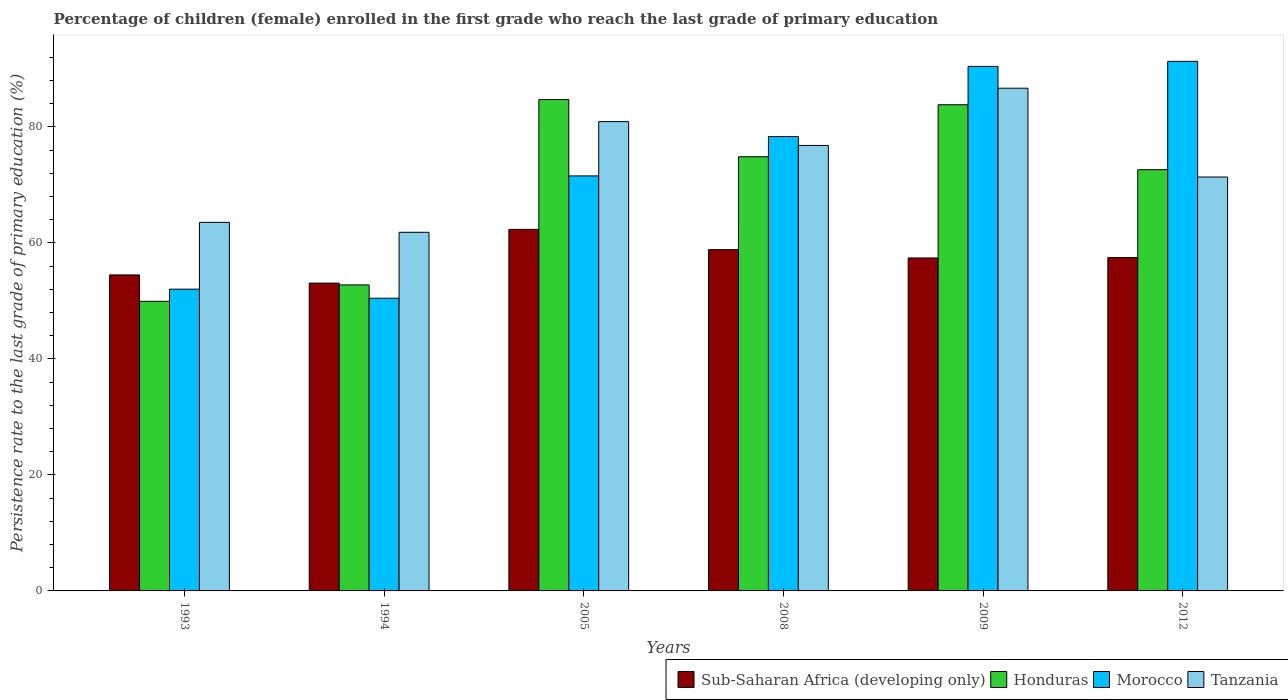How many different coloured bars are there?
Keep it short and to the point. 4. How many bars are there on the 1st tick from the left?
Your response must be concise. 4. How many bars are there on the 4th tick from the right?
Your response must be concise. 4. In how many cases, is the number of bars for a given year not equal to the number of legend labels?
Your answer should be compact. 0. What is the persistence rate of children in Sub-Saharan Africa (developing only) in 2009?
Your response must be concise. 57.41. Across all years, what is the maximum persistence rate of children in Honduras?
Provide a succinct answer. 84.72. Across all years, what is the minimum persistence rate of children in Morocco?
Make the answer very short. 50.47. In which year was the persistence rate of children in Sub-Saharan Africa (developing only) maximum?
Ensure brevity in your answer.  2005. What is the total persistence rate of children in Morocco in the graph?
Provide a succinct answer. 434.16. What is the difference between the persistence rate of children in Honduras in 1993 and that in 2009?
Ensure brevity in your answer.  -33.9. What is the difference between the persistence rate of children in Honduras in 2008 and the persistence rate of children in Morocco in 2005?
Offer a very short reply. 3.31. What is the average persistence rate of children in Tanzania per year?
Provide a short and direct response. 73.53. In the year 1994, what is the difference between the persistence rate of children in Tanzania and persistence rate of children in Honduras?
Provide a succinct answer. 9.07. In how many years, is the persistence rate of children in Tanzania greater than 64 %?
Your answer should be very brief. 4. What is the ratio of the persistence rate of children in Honduras in 1994 to that in 2012?
Your response must be concise. 0.73. Is the persistence rate of children in Sub-Saharan Africa (developing only) in 2005 less than that in 2008?
Your answer should be very brief. No. Is the difference between the persistence rate of children in Tanzania in 1993 and 1994 greater than the difference between the persistence rate of children in Honduras in 1993 and 1994?
Your answer should be very brief. Yes. What is the difference between the highest and the second highest persistence rate of children in Sub-Saharan Africa (developing only)?
Give a very brief answer. 3.5. What is the difference between the highest and the lowest persistence rate of children in Morocco?
Your response must be concise. 40.85. In how many years, is the persistence rate of children in Honduras greater than the average persistence rate of children in Honduras taken over all years?
Offer a terse response. 4. Is the sum of the persistence rate of children in Morocco in 2005 and 2012 greater than the maximum persistence rate of children in Tanzania across all years?
Your response must be concise. Yes. What does the 4th bar from the left in 1994 represents?
Make the answer very short. Tanzania. What does the 1st bar from the right in 1994 represents?
Provide a succinct answer. Tanzania. How many bars are there?
Provide a succinct answer. 24. How many years are there in the graph?
Keep it short and to the point. 6. What is the difference between two consecutive major ticks on the Y-axis?
Offer a terse response. 20. Are the values on the major ticks of Y-axis written in scientific E-notation?
Ensure brevity in your answer.  No. Does the graph contain grids?
Make the answer very short. No. How many legend labels are there?
Provide a succinct answer. 4. What is the title of the graph?
Your answer should be very brief. Percentage of children (female) enrolled in the first grade who reach the last grade of primary education. What is the label or title of the X-axis?
Keep it short and to the point. Years. What is the label or title of the Y-axis?
Your answer should be very brief. Persistence rate to the last grade of primary education (%). What is the Persistence rate to the last grade of primary education (%) of Sub-Saharan Africa (developing only) in 1993?
Provide a short and direct response. 54.49. What is the Persistence rate to the last grade of primary education (%) in Honduras in 1993?
Keep it short and to the point. 49.94. What is the Persistence rate to the last grade of primary education (%) in Morocco in 1993?
Keep it short and to the point. 52.03. What is the Persistence rate to the last grade of primary education (%) in Tanzania in 1993?
Offer a very short reply. 63.55. What is the Persistence rate to the last grade of primary education (%) of Sub-Saharan Africa (developing only) in 1994?
Your answer should be compact. 53.08. What is the Persistence rate to the last grade of primary education (%) of Honduras in 1994?
Offer a very short reply. 52.77. What is the Persistence rate to the last grade of primary education (%) in Morocco in 1994?
Keep it short and to the point. 50.47. What is the Persistence rate to the last grade of primary education (%) in Tanzania in 1994?
Give a very brief answer. 61.84. What is the Persistence rate to the last grade of primary education (%) in Sub-Saharan Africa (developing only) in 2005?
Your response must be concise. 62.34. What is the Persistence rate to the last grade of primary education (%) of Honduras in 2005?
Your answer should be very brief. 84.72. What is the Persistence rate to the last grade of primary education (%) in Morocco in 2005?
Ensure brevity in your answer.  71.56. What is the Persistence rate to the last grade of primary education (%) in Tanzania in 2005?
Ensure brevity in your answer.  80.92. What is the Persistence rate to the last grade of primary education (%) of Sub-Saharan Africa (developing only) in 2008?
Provide a short and direct response. 58.85. What is the Persistence rate to the last grade of primary education (%) in Honduras in 2008?
Your response must be concise. 74.87. What is the Persistence rate to the last grade of primary education (%) of Morocco in 2008?
Give a very brief answer. 78.34. What is the Persistence rate to the last grade of primary education (%) in Tanzania in 2008?
Provide a short and direct response. 76.81. What is the Persistence rate to the last grade of primary education (%) of Sub-Saharan Africa (developing only) in 2009?
Provide a succinct answer. 57.41. What is the Persistence rate to the last grade of primary education (%) in Honduras in 2009?
Your answer should be compact. 83.83. What is the Persistence rate to the last grade of primary education (%) of Morocco in 2009?
Offer a terse response. 90.44. What is the Persistence rate to the last grade of primary education (%) in Tanzania in 2009?
Your answer should be very brief. 86.68. What is the Persistence rate to the last grade of primary education (%) of Sub-Saharan Africa (developing only) in 2012?
Ensure brevity in your answer.  57.48. What is the Persistence rate to the last grade of primary education (%) of Honduras in 2012?
Give a very brief answer. 72.63. What is the Persistence rate to the last grade of primary education (%) of Morocco in 2012?
Provide a short and direct response. 91.32. What is the Persistence rate to the last grade of primary education (%) in Tanzania in 2012?
Your answer should be compact. 71.37. Across all years, what is the maximum Persistence rate to the last grade of primary education (%) in Sub-Saharan Africa (developing only)?
Offer a terse response. 62.34. Across all years, what is the maximum Persistence rate to the last grade of primary education (%) of Honduras?
Give a very brief answer. 84.72. Across all years, what is the maximum Persistence rate to the last grade of primary education (%) in Morocco?
Provide a succinct answer. 91.32. Across all years, what is the maximum Persistence rate to the last grade of primary education (%) of Tanzania?
Offer a terse response. 86.68. Across all years, what is the minimum Persistence rate to the last grade of primary education (%) in Sub-Saharan Africa (developing only)?
Offer a very short reply. 53.08. Across all years, what is the minimum Persistence rate to the last grade of primary education (%) of Honduras?
Offer a terse response. 49.94. Across all years, what is the minimum Persistence rate to the last grade of primary education (%) of Morocco?
Your answer should be very brief. 50.47. Across all years, what is the minimum Persistence rate to the last grade of primary education (%) in Tanzania?
Give a very brief answer. 61.84. What is the total Persistence rate to the last grade of primary education (%) of Sub-Saharan Africa (developing only) in the graph?
Offer a very short reply. 343.65. What is the total Persistence rate to the last grade of primary education (%) in Honduras in the graph?
Give a very brief answer. 418.77. What is the total Persistence rate to the last grade of primary education (%) of Morocco in the graph?
Your answer should be compact. 434.16. What is the total Persistence rate to the last grade of primary education (%) in Tanzania in the graph?
Your response must be concise. 441.18. What is the difference between the Persistence rate to the last grade of primary education (%) in Sub-Saharan Africa (developing only) in 1993 and that in 1994?
Give a very brief answer. 1.41. What is the difference between the Persistence rate to the last grade of primary education (%) in Honduras in 1993 and that in 1994?
Offer a terse response. -2.83. What is the difference between the Persistence rate to the last grade of primary education (%) of Morocco in 1993 and that in 1994?
Keep it short and to the point. 1.56. What is the difference between the Persistence rate to the last grade of primary education (%) in Tanzania in 1993 and that in 1994?
Your answer should be very brief. 1.71. What is the difference between the Persistence rate to the last grade of primary education (%) of Sub-Saharan Africa (developing only) in 1993 and that in 2005?
Offer a very short reply. -7.86. What is the difference between the Persistence rate to the last grade of primary education (%) in Honduras in 1993 and that in 2005?
Offer a very short reply. -34.79. What is the difference between the Persistence rate to the last grade of primary education (%) of Morocco in 1993 and that in 2005?
Ensure brevity in your answer.  -19.53. What is the difference between the Persistence rate to the last grade of primary education (%) of Tanzania in 1993 and that in 2005?
Your response must be concise. -17.37. What is the difference between the Persistence rate to the last grade of primary education (%) in Sub-Saharan Africa (developing only) in 1993 and that in 2008?
Ensure brevity in your answer.  -4.36. What is the difference between the Persistence rate to the last grade of primary education (%) of Honduras in 1993 and that in 2008?
Keep it short and to the point. -24.93. What is the difference between the Persistence rate to the last grade of primary education (%) of Morocco in 1993 and that in 2008?
Your answer should be very brief. -26.31. What is the difference between the Persistence rate to the last grade of primary education (%) in Tanzania in 1993 and that in 2008?
Ensure brevity in your answer.  -13.26. What is the difference between the Persistence rate to the last grade of primary education (%) of Sub-Saharan Africa (developing only) in 1993 and that in 2009?
Give a very brief answer. -2.93. What is the difference between the Persistence rate to the last grade of primary education (%) in Honduras in 1993 and that in 2009?
Your answer should be very brief. -33.9. What is the difference between the Persistence rate to the last grade of primary education (%) of Morocco in 1993 and that in 2009?
Make the answer very short. -38.41. What is the difference between the Persistence rate to the last grade of primary education (%) in Tanzania in 1993 and that in 2009?
Your answer should be very brief. -23.13. What is the difference between the Persistence rate to the last grade of primary education (%) in Sub-Saharan Africa (developing only) in 1993 and that in 2012?
Offer a very short reply. -3. What is the difference between the Persistence rate to the last grade of primary education (%) in Honduras in 1993 and that in 2012?
Your answer should be compact. -22.7. What is the difference between the Persistence rate to the last grade of primary education (%) in Morocco in 1993 and that in 2012?
Offer a terse response. -39.28. What is the difference between the Persistence rate to the last grade of primary education (%) in Tanzania in 1993 and that in 2012?
Your answer should be very brief. -7.82. What is the difference between the Persistence rate to the last grade of primary education (%) in Sub-Saharan Africa (developing only) in 1994 and that in 2005?
Provide a short and direct response. -9.27. What is the difference between the Persistence rate to the last grade of primary education (%) of Honduras in 1994 and that in 2005?
Your response must be concise. -31.96. What is the difference between the Persistence rate to the last grade of primary education (%) in Morocco in 1994 and that in 2005?
Provide a succinct answer. -21.09. What is the difference between the Persistence rate to the last grade of primary education (%) of Tanzania in 1994 and that in 2005?
Provide a succinct answer. -19.08. What is the difference between the Persistence rate to the last grade of primary education (%) in Sub-Saharan Africa (developing only) in 1994 and that in 2008?
Give a very brief answer. -5.77. What is the difference between the Persistence rate to the last grade of primary education (%) in Honduras in 1994 and that in 2008?
Your answer should be very brief. -22.1. What is the difference between the Persistence rate to the last grade of primary education (%) in Morocco in 1994 and that in 2008?
Your response must be concise. -27.87. What is the difference between the Persistence rate to the last grade of primary education (%) of Tanzania in 1994 and that in 2008?
Your response must be concise. -14.97. What is the difference between the Persistence rate to the last grade of primary education (%) of Sub-Saharan Africa (developing only) in 1994 and that in 2009?
Your response must be concise. -4.34. What is the difference between the Persistence rate to the last grade of primary education (%) in Honduras in 1994 and that in 2009?
Your answer should be very brief. -31.07. What is the difference between the Persistence rate to the last grade of primary education (%) in Morocco in 1994 and that in 2009?
Give a very brief answer. -39.98. What is the difference between the Persistence rate to the last grade of primary education (%) of Tanzania in 1994 and that in 2009?
Offer a terse response. -24.84. What is the difference between the Persistence rate to the last grade of primary education (%) in Sub-Saharan Africa (developing only) in 1994 and that in 2012?
Your response must be concise. -4.41. What is the difference between the Persistence rate to the last grade of primary education (%) in Honduras in 1994 and that in 2012?
Offer a very short reply. -19.87. What is the difference between the Persistence rate to the last grade of primary education (%) of Morocco in 1994 and that in 2012?
Ensure brevity in your answer.  -40.85. What is the difference between the Persistence rate to the last grade of primary education (%) of Tanzania in 1994 and that in 2012?
Give a very brief answer. -9.53. What is the difference between the Persistence rate to the last grade of primary education (%) in Sub-Saharan Africa (developing only) in 2005 and that in 2008?
Your answer should be compact. 3.5. What is the difference between the Persistence rate to the last grade of primary education (%) in Honduras in 2005 and that in 2008?
Give a very brief answer. 9.86. What is the difference between the Persistence rate to the last grade of primary education (%) in Morocco in 2005 and that in 2008?
Give a very brief answer. -6.78. What is the difference between the Persistence rate to the last grade of primary education (%) of Tanzania in 2005 and that in 2008?
Your response must be concise. 4.11. What is the difference between the Persistence rate to the last grade of primary education (%) in Sub-Saharan Africa (developing only) in 2005 and that in 2009?
Provide a short and direct response. 4.93. What is the difference between the Persistence rate to the last grade of primary education (%) of Honduras in 2005 and that in 2009?
Offer a very short reply. 0.89. What is the difference between the Persistence rate to the last grade of primary education (%) of Morocco in 2005 and that in 2009?
Keep it short and to the point. -18.88. What is the difference between the Persistence rate to the last grade of primary education (%) in Tanzania in 2005 and that in 2009?
Your response must be concise. -5.76. What is the difference between the Persistence rate to the last grade of primary education (%) of Sub-Saharan Africa (developing only) in 2005 and that in 2012?
Your answer should be very brief. 4.86. What is the difference between the Persistence rate to the last grade of primary education (%) of Honduras in 2005 and that in 2012?
Your answer should be compact. 12.09. What is the difference between the Persistence rate to the last grade of primary education (%) of Morocco in 2005 and that in 2012?
Keep it short and to the point. -19.75. What is the difference between the Persistence rate to the last grade of primary education (%) of Tanzania in 2005 and that in 2012?
Your answer should be compact. 9.56. What is the difference between the Persistence rate to the last grade of primary education (%) in Sub-Saharan Africa (developing only) in 2008 and that in 2009?
Provide a short and direct response. 1.43. What is the difference between the Persistence rate to the last grade of primary education (%) in Honduras in 2008 and that in 2009?
Ensure brevity in your answer.  -8.97. What is the difference between the Persistence rate to the last grade of primary education (%) of Morocco in 2008 and that in 2009?
Your answer should be very brief. -12.1. What is the difference between the Persistence rate to the last grade of primary education (%) in Tanzania in 2008 and that in 2009?
Provide a short and direct response. -9.87. What is the difference between the Persistence rate to the last grade of primary education (%) of Sub-Saharan Africa (developing only) in 2008 and that in 2012?
Make the answer very short. 1.36. What is the difference between the Persistence rate to the last grade of primary education (%) in Honduras in 2008 and that in 2012?
Ensure brevity in your answer.  2.23. What is the difference between the Persistence rate to the last grade of primary education (%) of Morocco in 2008 and that in 2012?
Your answer should be very brief. -12.97. What is the difference between the Persistence rate to the last grade of primary education (%) in Tanzania in 2008 and that in 2012?
Provide a succinct answer. 5.44. What is the difference between the Persistence rate to the last grade of primary education (%) of Sub-Saharan Africa (developing only) in 2009 and that in 2012?
Give a very brief answer. -0.07. What is the difference between the Persistence rate to the last grade of primary education (%) in Honduras in 2009 and that in 2012?
Keep it short and to the point. 11.2. What is the difference between the Persistence rate to the last grade of primary education (%) in Morocco in 2009 and that in 2012?
Provide a short and direct response. -0.87. What is the difference between the Persistence rate to the last grade of primary education (%) in Tanzania in 2009 and that in 2012?
Offer a very short reply. 15.31. What is the difference between the Persistence rate to the last grade of primary education (%) of Sub-Saharan Africa (developing only) in 1993 and the Persistence rate to the last grade of primary education (%) of Honduras in 1994?
Provide a short and direct response. 1.72. What is the difference between the Persistence rate to the last grade of primary education (%) in Sub-Saharan Africa (developing only) in 1993 and the Persistence rate to the last grade of primary education (%) in Morocco in 1994?
Your answer should be compact. 4.02. What is the difference between the Persistence rate to the last grade of primary education (%) in Sub-Saharan Africa (developing only) in 1993 and the Persistence rate to the last grade of primary education (%) in Tanzania in 1994?
Make the answer very short. -7.35. What is the difference between the Persistence rate to the last grade of primary education (%) in Honduras in 1993 and the Persistence rate to the last grade of primary education (%) in Morocco in 1994?
Your answer should be compact. -0.53. What is the difference between the Persistence rate to the last grade of primary education (%) in Honduras in 1993 and the Persistence rate to the last grade of primary education (%) in Tanzania in 1994?
Your answer should be very brief. -11.9. What is the difference between the Persistence rate to the last grade of primary education (%) of Morocco in 1993 and the Persistence rate to the last grade of primary education (%) of Tanzania in 1994?
Provide a succinct answer. -9.81. What is the difference between the Persistence rate to the last grade of primary education (%) of Sub-Saharan Africa (developing only) in 1993 and the Persistence rate to the last grade of primary education (%) of Honduras in 2005?
Offer a terse response. -30.24. What is the difference between the Persistence rate to the last grade of primary education (%) of Sub-Saharan Africa (developing only) in 1993 and the Persistence rate to the last grade of primary education (%) of Morocco in 2005?
Offer a very short reply. -17.07. What is the difference between the Persistence rate to the last grade of primary education (%) of Sub-Saharan Africa (developing only) in 1993 and the Persistence rate to the last grade of primary education (%) of Tanzania in 2005?
Make the answer very short. -26.44. What is the difference between the Persistence rate to the last grade of primary education (%) in Honduras in 1993 and the Persistence rate to the last grade of primary education (%) in Morocco in 2005?
Ensure brevity in your answer.  -21.62. What is the difference between the Persistence rate to the last grade of primary education (%) in Honduras in 1993 and the Persistence rate to the last grade of primary education (%) in Tanzania in 2005?
Your answer should be compact. -30.99. What is the difference between the Persistence rate to the last grade of primary education (%) in Morocco in 1993 and the Persistence rate to the last grade of primary education (%) in Tanzania in 2005?
Keep it short and to the point. -28.89. What is the difference between the Persistence rate to the last grade of primary education (%) in Sub-Saharan Africa (developing only) in 1993 and the Persistence rate to the last grade of primary education (%) in Honduras in 2008?
Offer a very short reply. -20.38. What is the difference between the Persistence rate to the last grade of primary education (%) of Sub-Saharan Africa (developing only) in 1993 and the Persistence rate to the last grade of primary education (%) of Morocco in 2008?
Make the answer very short. -23.86. What is the difference between the Persistence rate to the last grade of primary education (%) in Sub-Saharan Africa (developing only) in 1993 and the Persistence rate to the last grade of primary education (%) in Tanzania in 2008?
Your answer should be compact. -22.33. What is the difference between the Persistence rate to the last grade of primary education (%) of Honduras in 1993 and the Persistence rate to the last grade of primary education (%) of Morocco in 2008?
Your answer should be compact. -28.41. What is the difference between the Persistence rate to the last grade of primary education (%) of Honduras in 1993 and the Persistence rate to the last grade of primary education (%) of Tanzania in 2008?
Your response must be concise. -26.88. What is the difference between the Persistence rate to the last grade of primary education (%) in Morocco in 1993 and the Persistence rate to the last grade of primary education (%) in Tanzania in 2008?
Offer a terse response. -24.78. What is the difference between the Persistence rate to the last grade of primary education (%) of Sub-Saharan Africa (developing only) in 1993 and the Persistence rate to the last grade of primary education (%) of Honduras in 2009?
Provide a succinct answer. -29.35. What is the difference between the Persistence rate to the last grade of primary education (%) in Sub-Saharan Africa (developing only) in 1993 and the Persistence rate to the last grade of primary education (%) in Morocco in 2009?
Ensure brevity in your answer.  -35.96. What is the difference between the Persistence rate to the last grade of primary education (%) of Sub-Saharan Africa (developing only) in 1993 and the Persistence rate to the last grade of primary education (%) of Tanzania in 2009?
Provide a succinct answer. -32.2. What is the difference between the Persistence rate to the last grade of primary education (%) in Honduras in 1993 and the Persistence rate to the last grade of primary education (%) in Morocco in 2009?
Provide a short and direct response. -40.51. What is the difference between the Persistence rate to the last grade of primary education (%) of Honduras in 1993 and the Persistence rate to the last grade of primary education (%) of Tanzania in 2009?
Your answer should be compact. -36.75. What is the difference between the Persistence rate to the last grade of primary education (%) of Morocco in 1993 and the Persistence rate to the last grade of primary education (%) of Tanzania in 2009?
Make the answer very short. -34.65. What is the difference between the Persistence rate to the last grade of primary education (%) of Sub-Saharan Africa (developing only) in 1993 and the Persistence rate to the last grade of primary education (%) of Honduras in 2012?
Provide a succinct answer. -18.15. What is the difference between the Persistence rate to the last grade of primary education (%) of Sub-Saharan Africa (developing only) in 1993 and the Persistence rate to the last grade of primary education (%) of Morocco in 2012?
Offer a terse response. -36.83. What is the difference between the Persistence rate to the last grade of primary education (%) in Sub-Saharan Africa (developing only) in 1993 and the Persistence rate to the last grade of primary education (%) in Tanzania in 2012?
Give a very brief answer. -16.88. What is the difference between the Persistence rate to the last grade of primary education (%) of Honduras in 1993 and the Persistence rate to the last grade of primary education (%) of Morocco in 2012?
Keep it short and to the point. -41.38. What is the difference between the Persistence rate to the last grade of primary education (%) in Honduras in 1993 and the Persistence rate to the last grade of primary education (%) in Tanzania in 2012?
Your answer should be compact. -21.43. What is the difference between the Persistence rate to the last grade of primary education (%) in Morocco in 1993 and the Persistence rate to the last grade of primary education (%) in Tanzania in 2012?
Give a very brief answer. -19.34. What is the difference between the Persistence rate to the last grade of primary education (%) in Sub-Saharan Africa (developing only) in 1994 and the Persistence rate to the last grade of primary education (%) in Honduras in 2005?
Make the answer very short. -31.65. What is the difference between the Persistence rate to the last grade of primary education (%) in Sub-Saharan Africa (developing only) in 1994 and the Persistence rate to the last grade of primary education (%) in Morocco in 2005?
Your response must be concise. -18.48. What is the difference between the Persistence rate to the last grade of primary education (%) in Sub-Saharan Africa (developing only) in 1994 and the Persistence rate to the last grade of primary education (%) in Tanzania in 2005?
Ensure brevity in your answer.  -27.85. What is the difference between the Persistence rate to the last grade of primary education (%) of Honduras in 1994 and the Persistence rate to the last grade of primary education (%) of Morocco in 2005?
Your response must be concise. -18.79. What is the difference between the Persistence rate to the last grade of primary education (%) in Honduras in 1994 and the Persistence rate to the last grade of primary education (%) in Tanzania in 2005?
Give a very brief answer. -28.16. What is the difference between the Persistence rate to the last grade of primary education (%) in Morocco in 1994 and the Persistence rate to the last grade of primary education (%) in Tanzania in 2005?
Keep it short and to the point. -30.46. What is the difference between the Persistence rate to the last grade of primary education (%) of Sub-Saharan Africa (developing only) in 1994 and the Persistence rate to the last grade of primary education (%) of Honduras in 2008?
Offer a terse response. -21.79. What is the difference between the Persistence rate to the last grade of primary education (%) of Sub-Saharan Africa (developing only) in 1994 and the Persistence rate to the last grade of primary education (%) of Morocco in 2008?
Your answer should be compact. -25.26. What is the difference between the Persistence rate to the last grade of primary education (%) in Sub-Saharan Africa (developing only) in 1994 and the Persistence rate to the last grade of primary education (%) in Tanzania in 2008?
Provide a succinct answer. -23.74. What is the difference between the Persistence rate to the last grade of primary education (%) in Honduras in 1994 and the Persistence rate to the last grade of primary education (%) in Morocco in 2008?
Ensure brevity in your answer.  -25.58. What is the difference between the Persistence rate to the last grade of primary education (%) of Honduras in 1994 and the Persistence rate to the last grade of primary education (%) of Tanzania in 2008?
Ensure brevity in your answer.  -24.05. What is the difference between the Persistence rate to the last grade of primary education (%) of Morocco in 1994 and the Persistence rate to the last grade of primary education (%) of Tanzania in 2008?
Make the answer very short. -26.35. What is the difference between the Persistence rate to the last grade of primary education (%) of Sub-Saharan Africa (developing only) in 1994 and the Persistence rate to the last grade of primary education (%) of Honduras in 2009?
Provide a succinct answer. -30.76. What is the difference between the Persistence rate to the last grade of primary education (%) in Sub-Saharan Africa (developing only) in 1994 and the Persistence rate to the last grade of primary education (%) in Morocco in 2009?
Provide a short and direct response. -37.37. What is the difference between the Persistence rate to the last grade of primary education (%) in Sub-Saharan Africa (developing only) in 1994 and the Persistence rate to the last grade of primary education (%) in Tanzania in 2009?
Provide a succinct answer. -33.61. What is the difference between the Persistence rate to the last grade of primary education (%) in Honduras in 1994 and the Persistence rate to the last grade of primary education (%) in Morocco in 2009?
Your answer should be very brief. -37.68. What is the difference between the Persistence rate to the last grade of primary education (%) of Honduras in 1994 and the Persistence rate to the last grade of primary education (%) of Tanzania in 2009?
Give a very brief answer. -33.92. What is the difference between the Persistence rate to the last grade of primary education (%) in Morocco in 1994 and the Persistence rate to the last grade of primary education (%) in Tanzania in 2009?
Offer a very short reply. -36.22. What is the difference between the Persistence rate to the last grade of primary education (%) of Sub-Saharan Africa (developing only) in 1994 and the Persistence rate to the last grade of primary education (%) of Honduras in 2012?
Provide a succinct answer. -19.56. What is the difference between the Persistence rate to the last grade of primary education (%) in Sub-Saharan Africa (developing only) in 1994 and the Persistence rate to the last grade of primary education (%) in Morocco in 2012?
Give a very brief answer. -38.24. What is the difference between the Persistence rate to the last grade of primary education (%) in Sub-Saharan Africa (developing only) in 1994 and the Persistence rate to the last grade of primary education (%) in Tanzania in 2012?
Ensure brevity in your answer.  -18.29. What is the difference between the Persistence rate to the last grade of primary education (%) in Honduras in 1994 and the Persistence rate to the last grade of primary education (%) in Morocco in 2012?
Offer a very short reply. -38.55. What is the difference between the Persistence rate to the last grade of primary education (%) in Honduras in 1994 and the Persistence rate to the last grade of primary education (%) in Tanzania in 2012?
Offer a terse response. -18.6. What is the difference between the Persistence rate to the last grade of primary education (%) in Morocco in 1994 and the Persistence rate to the last grade of primary education (%) in Tanzania in 2012?
Keep it short and to the point. -20.9. What is the difference between the Persistence rate to the last grade of primary education (%) of Sub-Saharan Africa (developing only) in 2005 and the Persistence rate to the last grade of primary education (%) of Honduras in 2008?
Provide a short and direct response. -12.52. What is the difference between the Persistence rate to the last grade of primary education (%) in Sub-Saharan Africa (developing only) in 2005 and the Persistence rate to the last grade of primary education (%) in Morocco in 2008?
Provide a succinct answer. -16. What is the difference between the Persistence rate to the last grade of primary education (%) in Sub-Saharan Africa (developing only) in 2005 and the Persistence rate to the last grade of primary education (%) in Tanzania in 2008?
Provide a short and direct response. -14.47. What is the difference between the Persistence rate to the last grade of primary education (%) of Honduras in 2005 and the Persistence rate to the last grade of primary education (%) of Morocco in 2008?
Ensure brevity in your answer.  6.38. What is the difference between the Persistence rate to the last grade of primary education (%) of Honduras in 2005 and the Persistence rate to the last grade of primary education (%) of Tanzania in 2008?
Make the answer very short. 7.91. What is the difference between the Persistence rate to the last grade of primary education (%) of Morocco in 2005 and the Persistence rate to the last grade of primary education (%) of Tanzania in 2008?
Make the answer very short. -5.25. What is the difference between the Persistence rate to the last grade of primary education (%) in Sub-Saharan Africa (developing only) in 2005 and the Persistence rate to the last grade of primary education (%) in Honduras in 2009?
Give a very brief answer. -21.49. What is the difference between the Persistence rate to the last grade of primary education (%) of Sub-Saharan Africa (developing only) in 2005 and the Persistence rate to the last grade of primary education (%) of Morocco in 2009?
Give a very brief answer. -28.1. What is the difference between the Persistence rate to the last grade of primary education (%) of Sub-Saharan Africa (developing only) in 2005 and the Persistence rate to the last grade of primary education (%) of Tanzania in 2009?
Offer a terse response. -24.34. What is the difference between the Persistence rate to the last grade of primary education (%) in Honduras in 2005 and the Persistence rate to the last grade of primary education (%) in Morocco in 2009?
Keep it short and to the point. -5.72. What is the difference between the Persistence rate to the last grade of primary education (%) in Honduras in 2005 and the Persistence rate to the last grade of primary education (%) in Tanzania in 2009?
Ensure brevity in your answer.  -1.96. What is the difference between the Persistence rate to the last grade of primary education (%) in Morocco in 2005 and the Persistence rate to the last grade of primary education (%) in Tanzania in 2009?
Keep it short and to the point. -15.12. What is the difference between the Persistence rate to the last grade of primary education (%) in Sub-Saharan Africa (developing only) in 2005 and the Persistence rate to the last grade of primary education (%) in Honduras in 2012?
Your answer should be compact. -10.29. What is the difference between the Persistence rate to the last grade of primary education (%) in Sub-Saharan Africa (developing only) in 2005 and the Persistence rate to the last grade of primary education (%) in Morocco in 2012?
Provide a short and direct response. -28.97. What is the difference between the Persistence rate to the last grade of primary education (%) in Sub-Saharan Africa (developing only) in 2005 and the Persistence rate to the last grade of primary education (%) in Tanzania in 2012?
Provide a short and direct response. -9.03. What is the difference between the Persistence rate to the last grade of primary education (%) of Honduras in 2005 and the Persistence rate to the last grade of primary education (%) of Morocco in 2012?
Offer a very short reply. -6.59. What is the difference between the Persistence rate to the last grade of primary education (%) in Honduras in 2005 and the Persistence rate to the last grade of primary education (%) in Tanzania in 2012?
Provide a short and direct response. 13.35. What is the difference between the Persistence rate to the last grade of primary education (%) of Morocco in 2005 and the Persistence rate to the last grade of primary education (%) of Tanzania in 2012?
Keep it short and to the point. 0.19. What is the difference between the Persistence rate to the last grade of primary education (%) of Sub-Saharan Africa (developing only) in 2008 and the Persistence rate to the last grade of primary education (%) of Honduras in 2009?
Keep it short and to the point. -24.99. What is the difference between the Persistence rate to the last grade of primary education (%) of Sub-Saharan Africa (developing only) in 2008 and the Persistence rate to the last grade of primary education (%) of Morocco in 2009?
Provide a succinct answer. -31.6. What is the difference between the Persistence rate to the last grade of primary education (%) in Sub-Saharan Africa (developing only) in 2008 and the Persistence rate to the last grade of primary education (%) in Tanzania in 2009?
Your response must be concise. -27.84. What is the difference between the Persistence rate to the last grade of primary education (%) of Honduras in 2008 and the Persistence rate to the last grade of primary education (%) of Morocco in 2009?
Ensure brevity in your answer.  -15.58. What is the difference between the Persistence rate to the last grade of primary education (%) in Honduras in 2008 and the Persistence rate to the last grade of primary education (%) in Tanzania in 2009?
Your answer should be very brief. -11.82. What is the difference between the Persistence rate to the last grade of primary education (%) in Morocco in 2008 and the Persistence rate to the last grade of primary education (%) in Tanzania in 2009?
Your answer should be very brief. -8.34. What is the difference between the Persistence rate to the last grade of primary education (%) of Sub-Saharan Africa (developing only) in 2008 and the Persistence rate to the last grade of primary education (%) of Honduras in 2012?
Make the answer very short. -13.79. What is the difference between the Persistence rate to the last grade of primary education (%) of Sub-Saharan Africa (developing only) in 2008 and the Persistence rate to the last grade of primary education (%) of Morocco in 2012?
Your answer should be very brief. -32.47. What is the difference between the Persistence rate to the last grade of primary education (%) in Sub-Saharan Africa (developing only) in 2008 and the Persistence rate to the last grade of primary education (%) in Tanzania in 2012?
Make the answer very short. -12.52. What is the difference between the Persistence rate to the last grade of primary education (%) in Honduras in 2008 and the Persistence rate to the last grade of primary education (%) in Morocco in 2012?
Offer a terse response. -16.45. What is the difference between the Persistence rate to the last grade of primary education (%) of Honduras in 2008 and the Persistence rate to the last grade of primary education (%) of Tanzania in 2012?
Your answer should be very brief. 3.5. What is the difference between the Persistence rate to the last grade of primary education (%) in Morocco in 2008 and the Persistence rate to the last grade of primary education (%) in Tanzania in 2012?
Your answer should be compact. 6.97. What is the difference between the Persistence rate to the last grade of primary education (%) in Sub-Saharan Africa (developing only) in 2009 and the Persistence rate to the last grade of primary education (%) in Honduras in 2012?
Offer a terse response. -15.22. What is the difference between the Persistence rate to the last grade of primary education (%) in Sub-Saharan Africa (developing only) in 2009 and the Persistence rate to the last grade of primary education (%) in Morocco in 2012?
Offer a very short reply. -33.9. What is the difference between the Persistence rate to the last grade of primary education (%) of Sub-Saharan Africa (developing only) in 2009 and the Persistence rate to the last grade of primary education (%) of Tanzania in 2012?
Your answer should be compact. -13.96. What is the difference between the Persistence rate to the last grade of primary education (%) in Honduras in 2009 and the Persistence rate to the last grade of primary education (%) in Morocco in 2012?
Offer a terse response. -7.48. What is the difference between the Persistence rate to the last grade of primary education (%) of Honduras in 2009 and the Persistence rate to the last grade of primary education (%) of Tanzania in 2012?
Make the answer very short. 12.46. What is the difference between the Persistence rate to the last grade of primary education (%) of Morocco in 2009 and the Persistence rate to the last grade of primary education (%) of Tanzania in 2012?
Provide a succinct answer. 19.07. What is the average Persistence rate to the last grade of primary education (%) in Sub-Saharan Africa (developing only) per year?
Your answer should be compact. 57.28. What is the average Persistence rate to the last grade of primary education (%) in Honduras per year?
Your answer should be compact. 69.79. What is the average Persistence rate to the last grade of primary education (%) of Morocco per year?
Keep it short and to the point. 72.36. What is the average Persistence rate to the last grade of primary education (%) of Tanzania per year?
Your response must be concise. 73.53. In the year 1993, what is the difference between the Persistence rate to the last grade of primary education (%) in Sub-Saharan Africa (developing only) and Persistence rate to the last grade of primary education (%) in Honduras?
Offer a very short reply. 4.55. In the year 1993, what is the difference between the Persistence rate to the last grade of primary education (%) in Sub-Saharan Africa (developing only) and Persistence rate to the last grade of primary education (%) in Morocco?
Offer a very short reply. 2.46. In the year 1993, what is the difference between the Persistence rate to the last grade of primary education (%) in Sub-Saharan Africa (developing only) and Persistence rate to the last grade of primary education (%) in Tanzania?
Your answer should be compact. -9.06. In the year 1993, what is the difference between the Persistence rate to the last grade of primary education (%) of Honduras and Persistence rate to the last grade of primary education (%) of Morocco?
Offer a terse response. -2.09. In the year 1993, what is the difference between the Persistence rate to the last grade of primary education (%) of Honduras and Persistence rate to the last grade of primary education (%) of Tanzania?
Keep it short and to the point. -13.61. In the year 1993, what is the difference between the Persistence rate to the last grade of primary education (%) of Morocco and Persistence rate to the last grade of primary education (%) of Tanzania?
Provide a succinct answer. -11.52. In the year 1994, what is the difference between the Persistence rate to the last grade of primary education (%) of Sub-Saharan Africa (developing only) and Persistence rate to the last grade of primary education (%) of Honduras?
Provide a succinct answer. 0.31. In the year 1994, what is the difference between the Persistence rate to the last grade of primary education (%) in Sub-Saharan Africa (developing only) and Persistence rate to the last grade of primary education (%) in Morocco?
Your answer should be very brief. 2.61. In the year 1994, what is the difference between the Persistence rate to the last grade of primary education (%) of Sub-Saharan Africa (developing only) and Persistence rate to the last grade of primary education (%) of Tanzania?
Offer a very short reply. -8.76. In the year 1994, what is the difference between the Persistence rate to the last grade of primary education (%) in Honduras and Persistence rate to the last grade of primary education (%) in Morocco?
Give a very brief answer. 2.3. In the year 1994, what is the difference between the Persistence rate to the last grade of primary education (%) in Honduras and Persistence rate to the last grade of primary education (%) in Tanzania?
Make the answer very short. -9.07. In the year 1994, what is the difference between the Persistence rate to the last grade of primary education (%) in Morocco and Persistence rate to the last grade of primary education (%) in Tanzania?
Provide a succinct answer. -11.37. In the year 2005, what is the difference between the Persistence rate to the last grade of primary education (%) of Sub-Saharan Africa (developing only) and Persistence rate to the last grade of primary education (%) of Honduras?
Make the answer very short. -22.38. In the year 2005, what is the difference between the Persistence rate to the last grade of primary education (%) of Sub-Saharan Africa (developing only) and Persistence rate to the last grade of primary education (%) of Morocco?
Ensure brevity in your answer.  -9.22. In the year 2005, what is the difference between the Persistence rate to the last grade of primary education (%) of Sub-Saharan Africa (developing only) and Persistence rate to the last grade of primary education (%) of Tanzania?
Your answer should be compact. -18.58. In the year 2005, what is the difference between the Persistence rate to the last grade of primary education (%) of Honduras and Persistence rate to the last grade of primary education (%) of Morocco?
Offer a very short reply. 13.16. In the year 2005, what is the difference between the Persistence rate to the last grade of primary education (%) of Honduras and Persistence rate to the last grade of primary education (%) of Tanzania?
Make the answer very short. 3.8. In the year 2005, what is the difference between the Persistence rate to the last grade of primary education (%) in Morocco and Persistence rate to the last grade of primary education (%) in Tanzania?
Keep it short and to the point. -9.36. In the year 2008, what is the difference between the Persistence rate to the last grade of primary education (%) of Sub-Saharan Africa (developing only) and Persistence rate to the last grade of primary education (%) of Honduras?
Your answer should be very brief. -16.02. In the year 2008, what is the difference between the Persistence rate to the last grade of primary education (%) of Sub-Saharan Africa (developing only) and Persistence rate to the last grade of primary education (%) of Morocco?
Offer a very short reply. -19.5. In the year 2008, what is the difference between the Persistence rate to the last grade of primary education (%) of Sub-Saharan Africa (developing only) and Persistence rate to the last grade of primary education (%) of Tanzania?
Keep it short and to the point. -17.97. In the year 2008, what is the difference between the Persistence rate to the last grade of primary education (%) in Honduras and Persistence rate to the last grade of primary education (%) in Morocco?
Offer a very short reply. -3.47. In the year 2008, what is the difference between the Persistence rate to the last grade of primary education (%) in Honduras and Persistence rate to the last grade of primary education (%) in Tanzania?
Your answer should be very brief. -1.95. In the year 2008, what is the difference between the Persistence rate to the last grade of primary education (%) in Morocco and Persistence rate to the last grade of primary education (%) in Tanzania?
Your answer should be compact. 1.53. In the year 2009, what is the difference between the Persistence rate to the last grade of primary education (%) in Sub-Saharan Africa (developing only) and Persistence rate to the last grade of primary education (%) in Honduras?
Ensure brevity in your answer.  -26.42. In the year 2009, what is the difference between the Persistence rate to the last grade of primary education (%) in Sub-Saharan Africa (developing only) and Persistence rate to the last grade of primary education (%) in Morocco?
Provide a succinct answer. -33.03. In the year 2009, what is the difference between the Persistence rate to the last grade of primary education (%) in Sub-Saharan Africa (developing only) and Persistence rate to the last grade of primary education (%) in Tanzania?
Offer a terse response. -29.27. In the year 2009, what is the difference between the Persistence rate to the last grade of primary education (%) of Honduras and Persistence rate to the last grade of primary education (%) of Morocco?
Keep it short and to the point. -6.61. In the year 2009, what is the difference between the Persistence rate to the last grade of primary education (%) in Honduras and Persistence rate to the last grade of primary education (%) in Tanzania?
Give a very brief answer. -2.85. In the year 2009, what is the difference between the Persistence rate to the last grade of primary education (%) of Morocco and Persistence rate to the last grade of primary education (%) of Tanzania?
Ensure brevity in your answer.  3.76. In the year 2012, what is the difference between the Persistence rate to the last grade of primary education (%) in Sub-Saharan Africa (developing only) and Persistence rate to the last grade of primary education (%) in Honduras?
Give a very brief answer. -15.15. In the year 2012, what is the difference between the Persistence rate to the last grade of primary education (%) of Sub-Saharan Africa (developing only) and Persistence rate to the last grade of primary education (%) of Morocco?
Give a very brief answer. -33.83. In the year 2012, what is the difference between the Persistence rate to the last grade of primary education (%) in Sub-Saharan Africa (developing only) and Persistence rate to the last grade of primary education (%) in Tanzania?
Your answer should be compact. -13.89. In the year 2012, what is the difference between the Persistence rate to the last grade of primary education (%) of Honduras and Persistence rate to the last grade of primary education (%) of Morocco?
Make the answer very short. -18.68. In the year 2012, what is the difference between the Persistence rate to the last grade of primary education (%) in Honduras and Persistence rate to the last grade of primary education (%) in Tanzania?
Offer a terse response. 1.27. In the year 2012, what is the difference between the Persistence rate to the last grade of primary education (%) in Morocco and Persistence rate to the last grade of primary education (%) in Tanzania?
Your response must be concise. 19.95. What is the ratio of the Persistence rate to the last grade of primary education (%) in Sub-Saharan Africa (developing only) in 1993 to that in 1994?
Provide a short and direct response. 1.03. What is the ratio of the Persistence rate to the last grade of primary education (%) of Honduras in 1993 to that in 1994?
Give a very brief answer. 0.95. What is the ratio of the Persistence rate to the last grade of primary education (%) of Morocco in 1993 to that in 1994?
Provide a succinct answer. 1.03. What is the ratio of the Persistence rate to the last grade of primary education (%) of Tanzania in 1993 to that in 1994?
Keep it short and to the point. 1.03. What is the ratio of the Persistence rate to the last grade of primary education (%) of Sub-Saharan Africa (developing only) in 1993 to that in 2005?
Give a very brief answer. 0.87. What is the ratio of the Persistence rate to the last grade of primary education (%) in Honduras in 1993 to that in 2005?
Provide a short and direct response. 0.59. What is the ratio of the Persistence rate to the last grade of primary education (%) in Morocco in 1993 to that in 2005?
Provide a succinct answer. 0.73. What is the ratio of the Persistence rate to the last grade of primary education (%) in Tanzania in 1993 to that in 2005?
Offer a terse response. 0.79. What is the ratio of the Persistence rate to the last grade of primary education (%) in Sub-Saharan Africa (developing only) in 1993 to that in 2008?
Offer a very short reply. 0.93. What is the ratio of the Persistence rate to the last grade of primary education (%) of Honduras in 1993 to that in 2008?
Ensure brevity in your answer.  0.67. What is the ratio of the Persistence rate to the last grade of primary education (%) in Morocco in 1993 to that in 2008?
Keep it short and to the point. 0.66. What is the ratio of the Persistence rate to the last grade of primary education (%) in Tanzania in 1993 to that in 2008?
Make the answer very short. 0.83. What is the ratio of the Persistence rate to the last grade of primary education (%) in Sub-Saharan Africa (developing only) in 1993 to that in 2009?
Offer a very short reply. 0.95. What is the ratio of the Persistence rate to the last grade of primary education (%) in Honduras in 1993 to that in 2009?
Make the answer very short. 0.6. What is the ratio of the Persistence rate to the last grade of primary education (%) of Morocco in 1993 to that in 2009?
Make the answer very short. 0.58. What is the ratio of the Persistence rate to the last grade of primary education (%) of Tanzania in 1993 to that in 2009?
Provide a succinct answer. 0.73. What is the ratio of the Persistence rate to the last grade of primary education (%) in Sub-Saharan Africa (developing only) in 1993 to that in 2012?
Your answer should be very brief. 0.95. What is the ratio of the Persistence rate to the last grade of primary education (%) in Honduras in 1993 to that in 2012?
Offer a very short reply. 0.69. What is the ratio of the Persistence rate to the last grade of primary education (%) in Morocco in 1993 to that in 2012?
Your response must be concise. 0.57. What is the ratio of the Persistence rate to the last grade of primary education (%) in Tanzania in 1993 to that in 2012?
Provide a short and direct response. 0.89. What is the ratio of the Persistence rate to the last grade of primary education (%) in Sub-Saharan Africa (developing only) in 1994 to that in 2005?
Ensure brevity in your answer.  0.85. What is the ratio of the Persistence rate to the last grade of primary education (%) of Honduras in 1994 to that in 2005?
Provide a short and direct response. 0.62. What is the ratio of the Persistence rate to the last grade of primary education (%) in Morocco in 1994 to that in 2005?
Make the answer very short. 0.71. What is the ratio of the Persistence rate to the last grade of primary education (%) of Tanzania in 1994 to that in 2005?
Provide a short and direct response. 0.76. What is the ratio of the Persistence rate to the last grade of primary education (%) of Sub-Saharan Africa (developing only) in 1994 to that in 2008?
Ensure brevity in your answer.  0.9. What is the ratio of the Persistence rate to the last grade of primary education (%) in Honduras in 1994 to that in 2008?
Provide a succinct answer. 0.7. What is the ratio of the Persistence rate to the last grade of primary education (%) in Morocco in 1994 to that in 2008?
Keep it short and to the point. 0.64. What is the ratio of the Persistence rate to the last grade of primary education (%) in Tanzania in 1994 to that in 2008?
Keep it short and to the point. 0.81. What is the ratio of the Persistence rate to the last grade of primary education (%) in Sub-Saharan Africa (developing only) in 1994 to that in 2009?
Offer a very short reply. 0.92. What is the ratio of the Persistence rate to the last grade of primary education (%) in Honduras in 1994 to that in 2009?
Your response must be concise. 0.63. What is the ratio of the Persistence rate to the last grade of primary education (%) of Morocco in 1994 to that in 2009?
Your answer should be compact. 0.56. What is the ratio of the Persistence rate to the last grade of primary education (%) in Tanzania in 1994 to that in 2009?
Your answer should be compact. 0.71. What is the ratio of the Persistence rate to the last grade of primary education (%) in Sub-Saharan Africa (developing only) in 1994 to that in 2012?
Provide a short and direct response. 0.92. What is the ratio of the Persistence rate to the last grade of primary education (%) in Honduras in 1994 to that in 2012?
Provide a short and direct response. 0.73. What is the ratio of the Persistence rate to the last grade of primary education (%) in Morocco in 1994 to that in 2012?
Provide a succinct answer. 0.55. What is the ratio of the Persistence rate to the last grade of primary education (%) of Tanzania in 1994 to that in 2012?
Your answer should be compact. 0.87. What is the ratio of the Persistence rate to the last grade of primary education (%) in Sub-Saharan Africa (developing only) in 2005 to that in 2008?
Provide a succinct answer. 1.06. What is the ratio of the Persistence rate to the last grade of primary education (%) in Honduras in 2005 to that in 2008?
Your response must be concise. 1.13. What is the ratio of the Persistence rate to the last grade of primary education (%) in Morocco in 2005 to that in 2008?
Keep it short and to the point. 0.91. What is the ratio of the Persistence rate to the last grade of primary education (%) of Tanzania in 2005 to that in 2008?
Keep it short and to the point. 1.05. What is the ratio of the Persistence rate to the last grade of primary education (%) of Sub-Saharan Africa (developing only) in 2005 to that in 2009?
Keep it short and to the point. 1.09. What is the ratio of the Persistence rate to the last grade of primary education (%) of Honduras in 2005 to that in 2009?
Give a very brief answer. 1.01. What is the ratio of the Persistence rate to the last grade of primary education (%) of Morocco in 2005 to that in 2009?
Your response must be concise. 0.79. What is the ratio of the Persistence rate to the last grade of primary education (%) in Tanzania in 2005 to that in 2009?
Offer a terse response. 0.93. What is the ratio of the Persistence rate to the last grade of primary education (%) of Sub-Saharan Africa (developing only) in 2005 to that in 2012?
Ensure brevity in your answer.  1.08. What is the ratio of the Persistence rate to the last grade of primary education (%) of Honduras in 2005 to that in 2012?
Offer a terse response. 1.17. What is the ratio of the Persistence rate to the last grade of primary education (%) of Morocco in 2005 to that in 2012?
Keep it short and to the point. 0.78. What is the ratio of the Persistence rate to the last grade of primary education (%) of Tanzania in 2005 to that in 2012?
Offer a terse response. 1.13. What is the ratio of the Persistence rate to the last grade of primary education (%) in Sub-Saharan Africa (developing only) in 2008 to that in 2009?
Give a very brief answer. 1.02. What is the ratio of the Persistence rate to the last grade of primary education (%) of Honduras in 2008 to that in 2009?
Offer a very short reply. 0.89. What is the ratio of the Persistence rate to the last grade of primary education (%) of Morocco in 2008 to that in 2009?
Make the answer very short. 0.87. What is the ratio of the Persistence rate to the last grade of primary education (%) in Tanzania in 2008 to that in 2009?
Offer a terse response. 0.89. What is the ratio of the Persistence rate to the last grade of primary education (%) of Sub-Saharan Africa (developing only) in 2008 to that in 2012?
Your response must be concise. 1.02. What is the ratio of the Persistence rate to the last grade of primary education (%) of Honduras in 2008 to that in 2012?
Your response must be concise. 1.03. What is the ratio of the Persistence rate to the last grade of primary education (%) in Morocco in 2008 to that in 2012?
Your response must be concise. 0.86. What is the ratio of the Persistence rate to the last grade of primary education (%) in Tanzania in 2008 to that in 2012?
Provide a succinct answer. 1.08. What is the ratio of the Persistence rate to the last grade of primary education (%) in Honduras in 2009 to that in 2012?
Offer a very short reply. 1.15. What is the ratio of the Persistence rate to the last grade of primary education (%) of Morocco in 2009 to that in 2012?
Keep it short and to the point. 0.99. What is the ratio of the Persistence rate to the last grade of primary education (%) of Tanzania in 2009 to that in 2012?
Provide a short and direct response. 1.21. What is the difference between the highest and the second highest Persistence rate to the last grade of primary education (%) in Sub-Saharan Africa (developing only)?
Offer a very short reply. 3.5. What is the difference between the highest and the second highest Persistence rate to the last grade of primary education (%) in Honduras?
Give a very brief answer. 0.89. What is the difference between the highest and the second highest Persistence rate to the last grade of primary education (%) of Morocco?
Your answer should be compact. 0.87. What is the difference between the highest and the second highest Persistence rate to the last grade of primary education (%) of Tanzania?
Provide a short and direct response. 5.76. What is the difference between the highest and the lowest Persistence rate to the last grade of primary education (%) of Sub-Saharan Africa (developing only)?
Offer a very short reply. 9.27. What is the difference between the highest and the lowest Persistence rate to the last grade of primary education (%) in Honduras?
Provide a short and direct response. 34.79. What is the difference between the highest and the lowest Persistence rate to the last grade of primary education (%) of Morocco?
Offer a very short reply. 40.85. What is the difference between the highest and the lowest Persistence rate to the last grade of primary education (%) in Tanzania?
Provide a succinct answer. 24.84. 